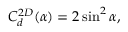<formula> <loc_0><loc_0><loc_500><loc_500>C _ { d } ^ { 2 D } ( \alpha ) = 2 \sin ^ { 2 } \alpha ,</formula> 